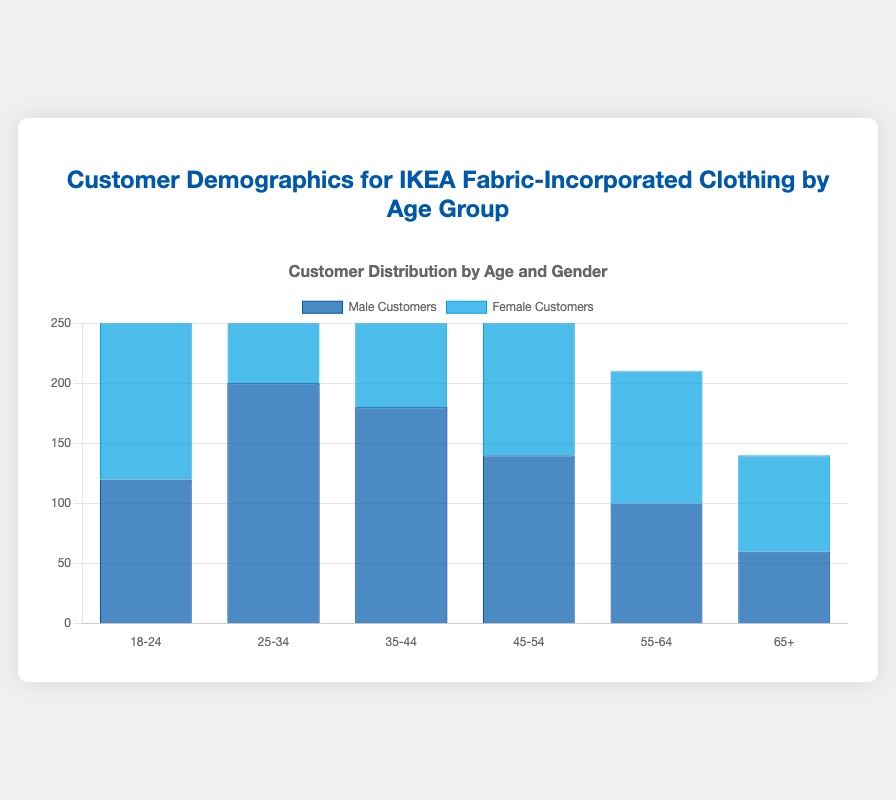Which age group has the highest number of female customers? Look at the height of the bars representing female customers in each age group and identify which bar is tallest. The age group 25-34 has the highest bar for female customers.
Answer: 25-34 What is the total number of customers (both male and female) in the 35-44 age group? Add the number of male customers (180) and female customers (190) in the 35-44 age group: 180 + 190 = 370.
Answer: 370 How does the number of male customers in the 18-24 age group compare to the number of male customers in the 45-54 age group? The number of male customers in the 18-24 age group is 120, while in the 45-54 age group it is 140. 140 is greater than 120.
Answer: 45-54 has more male customers Which gender has more customers in the 55-64 age group? Compare the height of the bars for male customers (100) and female customers (110) in the 55-64 age group. The bar for female customers is taller.
Answer: Female What's the overall difference in the number of customers between the age groups 25-34 and 65+? Calculate the total number of customers for both age groups. For 25-34: 200 (male) + 220 (female) = 420. For 65+: 60 (male) + 80 (female) = 140. The difference is 420 - 140 = 280.
Answer: 280 What is the combined number of female customers in the 18-24 and 45-54 age groups? Add the number of female customers from the 18-24 age group (150) to the 45-54 age group (160): 150 + 160 = 310.
Answer: 310 